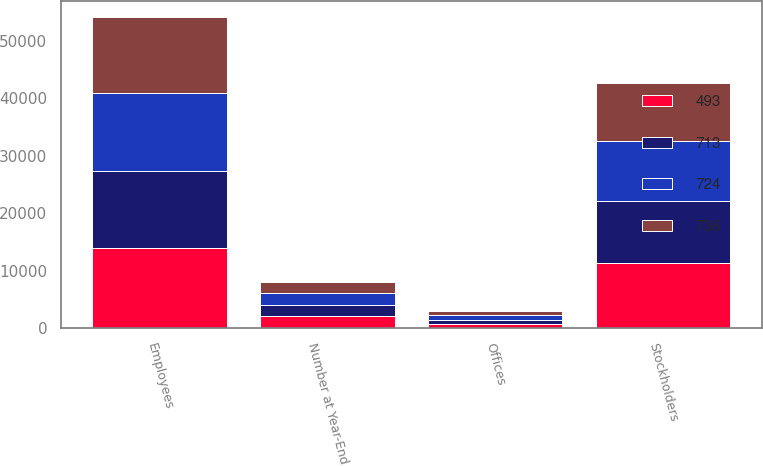<chart> <loc_0><loc_0><loc_500><loc_500><stacked_bar_chart><ecel><fcel>Number at Year-End<fcel>Stockholders<fcel>Employees<fcel>Offices<nl><fcel>736<fcel>2006<fcel>10084<fcel>13352<fcel>736<nl><fcel>724<fcel>2005<fcel>10437<fcel>13525<fcel>724<nl><fcel>713<fcel>2004<fcel>10857<fcel>13371<fcel>713<nl><fcel>493<fcel>2003<fcel>11258<fcel>14000<fcel>735<nl></chart> 